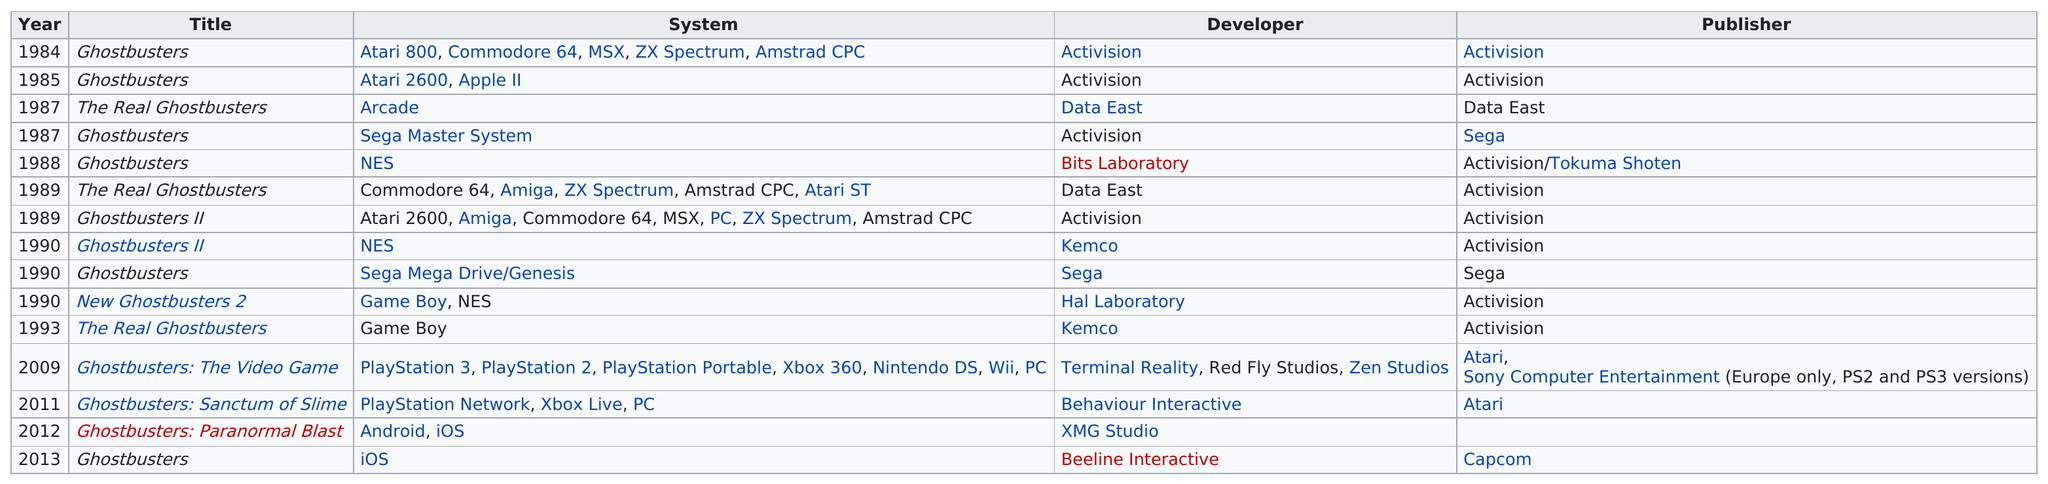Specify some key components in this picture. There have been a total of 15 Ghostbusters video games created. When Ghostbusters was released for the NES in 1988, it had previously been released for the Sega Master System. Activision has developed a significant number of games, and it is unclear what the exact total amount is. However, it can be asserted that Activision has developed a substantial quantity of games. During the period of 1988 to 1993, 7 games were produced. The Real Ghostbusters, a game developed in the year prior to 1994, was a game made in the year previous to 1994. 